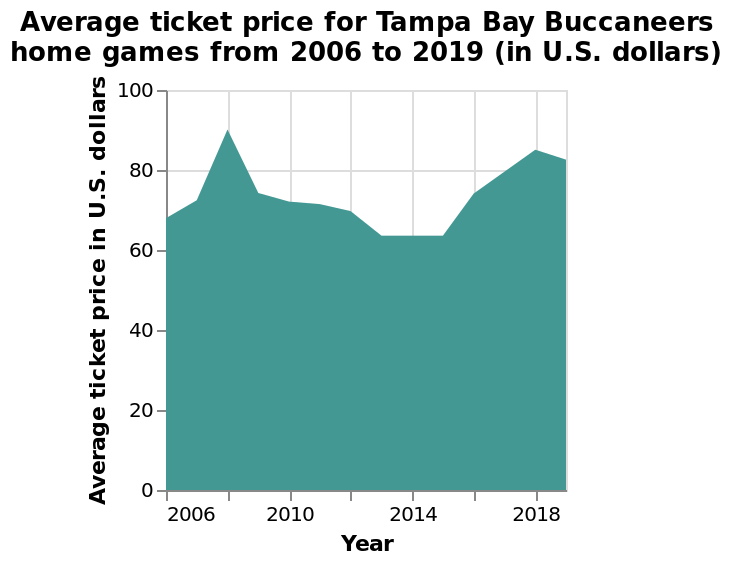<image>
In which year did we see a slight decline in ticket prices? Ticket prices saw a slight decline in 2019. What is represented on the y-axis of the chart?  The y-axis of the chart represents the average ticket price in U.S. dollars on a linear scale from 0 to 100. Describe the following image in detail This area chart is titled Average ticket price for Tampa Bay Buccaneers home games from 2006 to 2019 (in U.S. dollars). The y-axis measures Average ticket price in U.S. dollars on a linear scale from 0 to 100. A linear scale of range 2006 to 2018 can be seen on the x-axis, marked Year. Offer a thorough analysis of the image. Ticket prices would initially go up until 2008, and then see a decline in price until 2014 where it would go up again until 2018 then see a slight decline in 2019. 